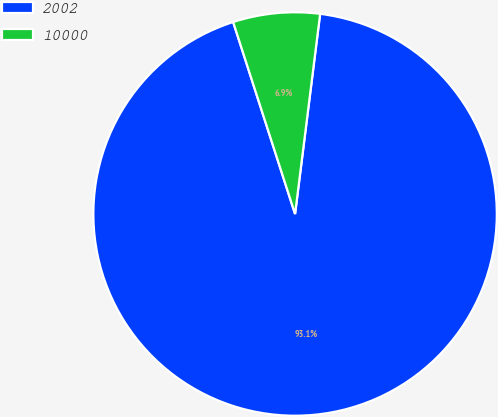Convert chart to OTSL. <chart><loc_0><loc_0><loc_500><loc_500><pie_chart><fcel>2002<fcel>10000<nl><fcel>93.05%<fcel>6.95%<nl></chart> 